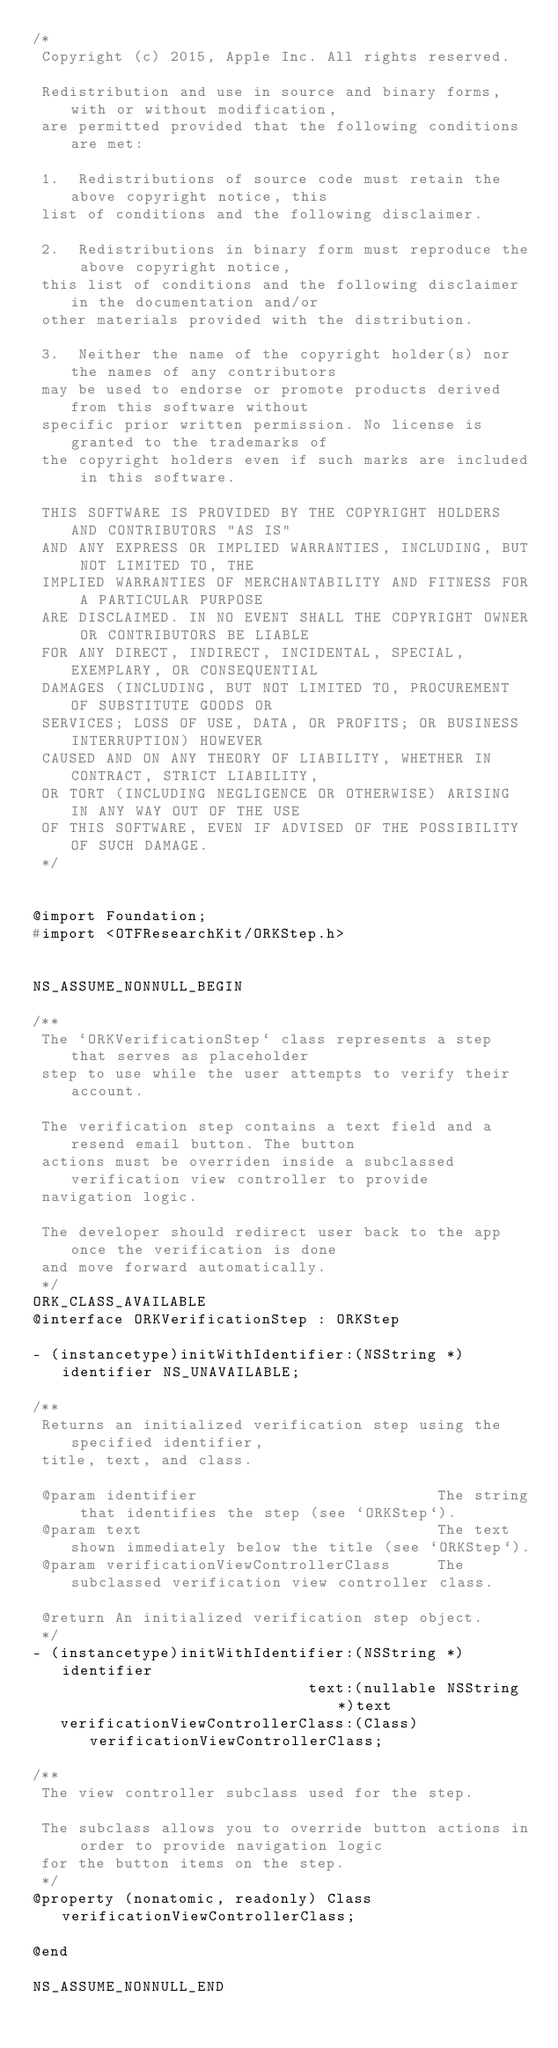<code> <loc_0><loc_0><loc_500><loc_500><_C_>/*
 Copyright (c) 2015, Apple Inc. All rights reserved.
 
 Redistribution and use in source and binary forms, with or without modification,
 are permitted provided that the following conditions are met:
 
 1.  Redistributions of source code must retain the above copyright notice, this
 list of conditions and the following disclaimer.
 
 2.  Redistributions in binary form must reproduce the above copyright notice,
 this list of conditions and the following disclaimer in the documentation and/or
 other materials provided with the distribution.
 
 3.  Neither the name of the copyright holder(s) nor the names of any contributors
 may be used to endorse or promote products derived from this software without
 specific prior written permission. No license is granted to the trademarks of
 the copyright holders even if such marks are included in this software.
 
 THIS SOFTWARE IS PROVIDED BY THE COPYRIGHT HOLDERS AND CONTRIBUTORS "AS IS"
 AND ANY EXPRESS OR IMPLIED WARRANTIES, INCLUDING, BUT NOT LIMITED TO, THE
 IMPLIED WARRANTIES OF MERCHANTABILITY AND FITNESS FOR A PARTICULAR PURPOSE
 ARE DISCLAIMED. IN NO EVENT SHALL THE COPYRIGHT OWNER OR CONTRIBUTORS BE LIABLE
 FOR ANY DIRECT, INDIRECT, INCIDENTAL, SPECIAL, EXEMPLARY, OR CONSEQUENTIAL
 DAMAGES (INCLUDING, BUT NOT LIMITED TO, PROCUREMENT OF SUBSTITUTE GOODS OR
 SERVICES; LOSS OF USE, DATA, OR PROFITS; OR BUSINESS INTERRUPTION) HOWEVER
 CAUSED AND ON ANY THEORY OF LIABILITY, WHETHER IN CONTRACT, STRICT LIABILITY,
 OR TORT (INCLUDING NEGLIGENCE OR OTHERWISE) ARISING IN ANY WAY OUT OF THE USE
 OF THIS SOFTWARE, EVEN IF ADVISED OF THE POSSIBILITY OF SUCH DAMAGE.
 */


@import Foundation;
#import <OTFResearchKit/ORKStep.h>


NS_ASSUME_NONNULL_BEGIN

/**
 The `ORKVerificationStep` class represents a step that serves as placeholder
 step to use while the user attempts to verify their account.
 
 The verification step contains a text field and a resend email button. The button 
 actions must be overriden inside a subclassed verification view controller to provide
 navigation logic.
 
 The developer should redirect user back to the app once the verification is done 
 and move forward automatically.
 */
ORK_CLASS_AVAILABLE
@interface ORKVerificationStep : ORKStep

- (instancetype)initWithIdentifier:(NSString *)identifier NS_UNAVAILABLE;

/**
 Returns an initialized verification step using the specified identifier,
 title, text, and class.
  
 @param identifier                          The string that identifies the step (see `ORKStep`).
 @param text                                The text shown immediately below the title (see `ORKStep`).
 @param verificationViewControllerClass     The subclassed verification view controller class.
 
 @return An initialized verification step object.
 */
- (instancetype)initWithIdentifier:(NSString *)identifier
                              text:(nullable NSString *)text
   verificationViewControllerClass:(Class)verificationViewControllerClass;

/**
 The view controller subclass used for the step.
 
 The subclass allows you to override button actions in order to provide navigation logic
 for the button items on the step.
 */
@property (nonatomic, readonly) Class verificationViewControllerClass;

@end

NS_ASSUME_NONNULL_END
</code> 